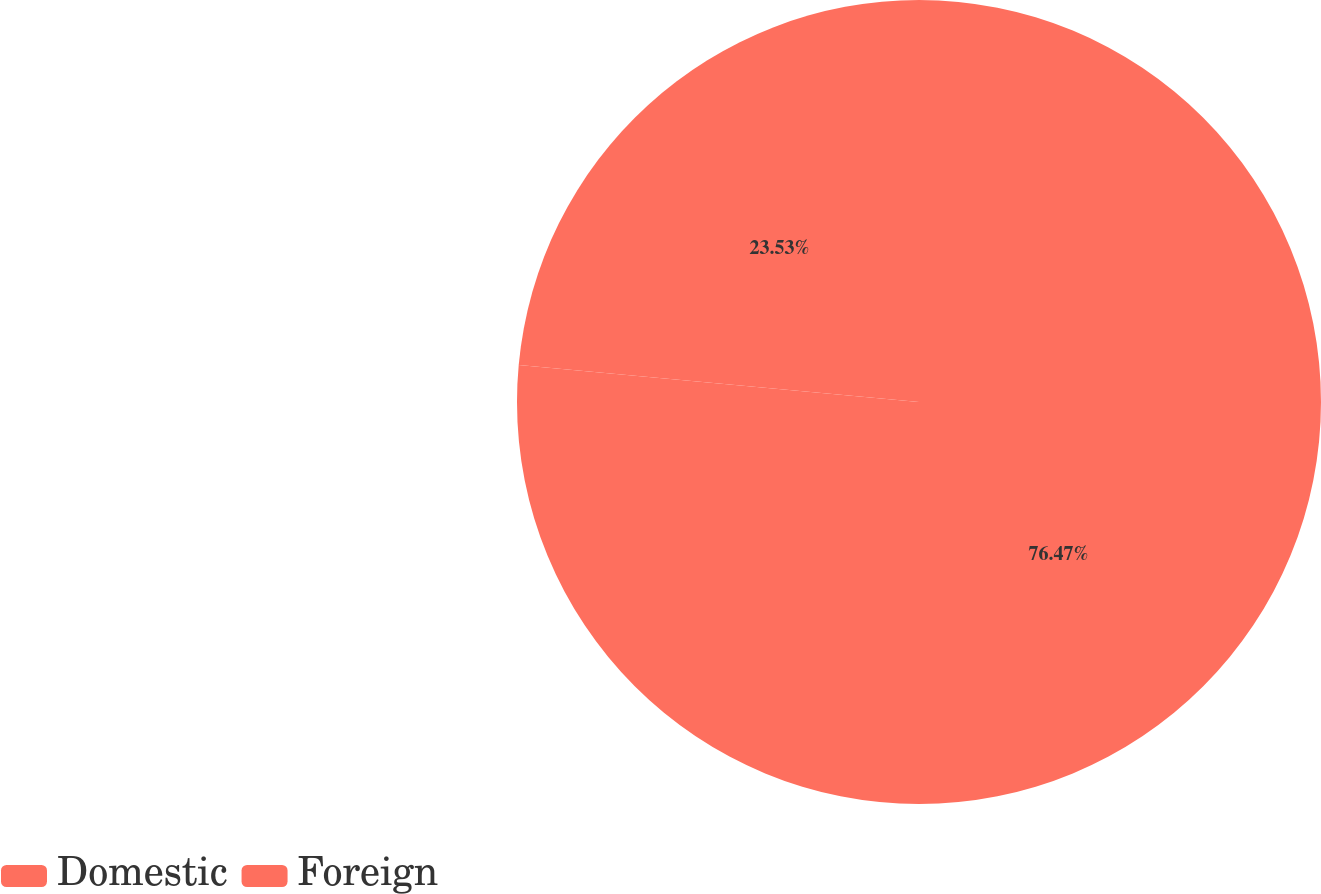Convert chart to OTSL. <chart><loc_0><loc_0><loc_500><loc_500><pie_chart><fcel>Domestic<fcel>Foreign<nl><fcel>76.47%<fcel>23.53%<nl></chart> 